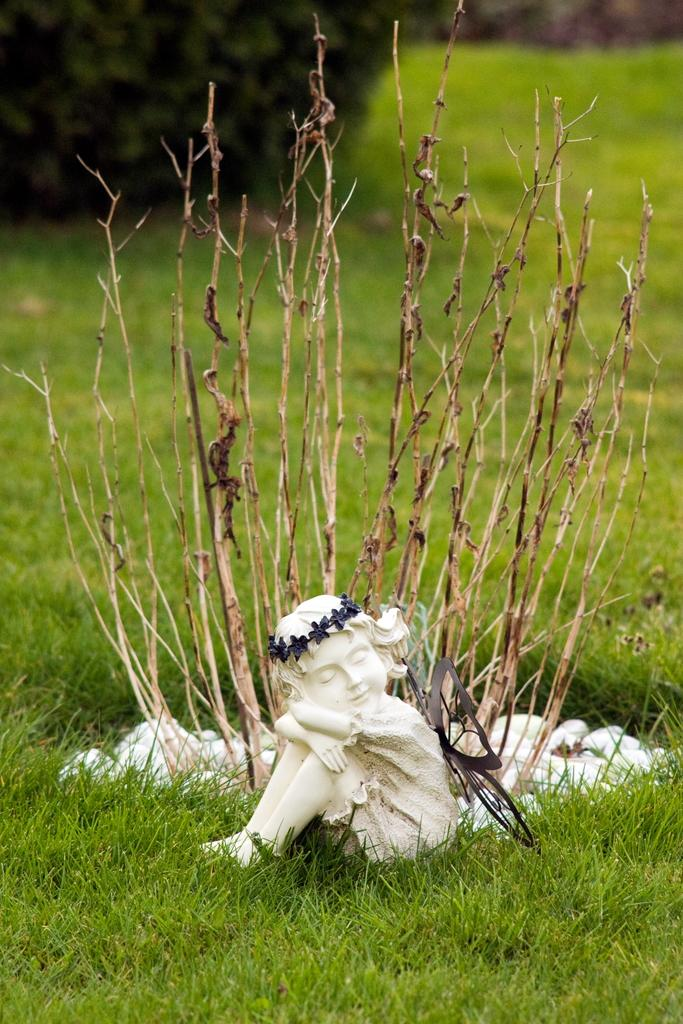What is located at the bottom of the image? There is a sculpture at the bottom of the image. What type of vegetation is present at the bottom of the image? Grass is present at the bottom of the image. What can be seen in the center of the image? There is a plant in the center of the image. What type of cake is being served in the winter season in the image? There is no cake or winter season depicted in the image; it features a sculpture, grass, and a plant. 